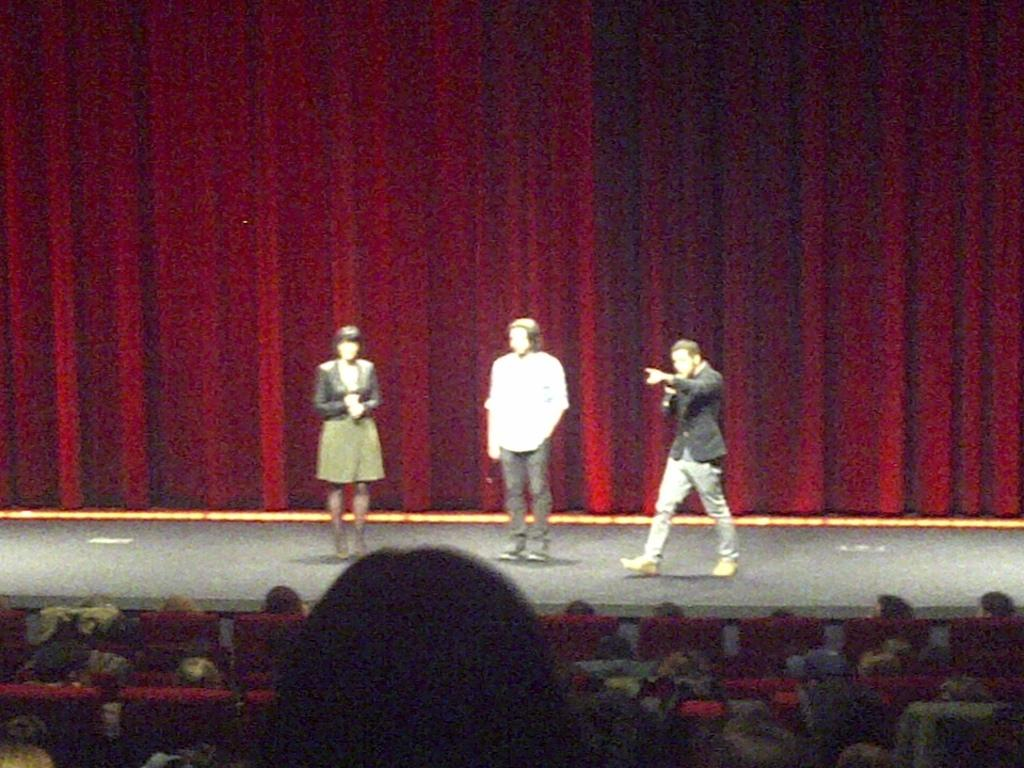Who or what can be seen in the image? There are people in the image. Can you describe the location of some people in the image? Some people are on a stage. What can be seen in the background of the image? There are curtains in the background of the image. What color is the pail being held by the person on the stage? There is no pail present in the image, so it cannot be determined what color it might be. 